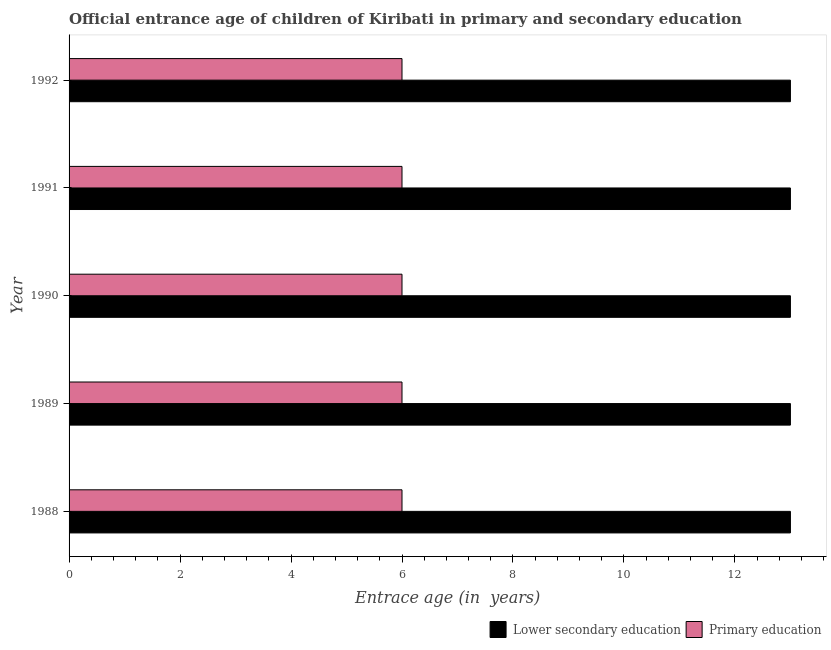How many different coloured bars are there?
Provide a succinct answer. 2. Are the number of bars per tick equal to the number of legend labels?
Offer a terse response. Yes. How many bars are there on the 4th tick from the top?
Provide a short and direct response. 2. What is the label of the 2nd group of bars from the top?
Offer a very short reply. 1991. Across all years, what is the minimum entrance age of children in lower secondary education?
Provide a succinct answer. 13. In which year was the entrance age of children in lower secondary education minimum?
Ensure brevity in your answer.  1988. What is the total entrance age of children in lower secondary education in the graph?
Keep it short and to the point. 65. What is the difference between the entrance age of children in lower secondary education in 1989 and the entrance age of chiildren in primary education in 1988?
Give a very brief answer. 7. What is the average entrance age of chiildren in primary education per year?
Keep it short and to the point. 6. In the year 1990, what is the difference between the entrance age of children in lower secondary education and entrance age of chiildren in primary education?
Provide a short and direct response. 7. In how many years, is the entrance age of chiildren in primary education greater than 6.8 years?
Provide a succinct answer. 0. Is the difference between the entrance age of chiildren in primary education in 1990 and 1991 greater than the difference between the entrance age of children in lower secondary education in 1990 and 1991?
Provide a short and direct response. No. What is the difference between the highest and the second highest entrance age of children in lower secondary education?
Ensure brevity in your answer.  0. What is the difference between the highest and the lowest entrance age of chiildren in primary education?
Offer a very short reply. 0. What does the 1st bar from the top in 1992 represents?
Ensure brevity in your answer.  Primary education. What does the 2nd bar from the bottom in 1989 represents?
Give a very brief answer. Primary education. How many bars are there?
Offer a terse response. 10. Are all the bars in the graph horizontal?
Offer a terse response. Yes. What is the difference between two consecutive major ticks on the X-axis?
Offer a terse response. 2. Where does the legend appear in the graph?
Your response must be concise. Bottom right. How are the legend labels stacked?
Ensure brevity in your answer.  Horizontal. What is the title of the graph?
Your response must be concise. Official entrance age of children of Kiribati in primary and secondary education. What is the label or title of the X-axis?
Offer a terse response. Entrace age (in  years). What is the Entrace age (in  years) in Lower secondary education in 1988?
Ensure brevity in your answer.  13. What is the Entrace age (in  years) of Primary education in 1988?
Ensure brevity in your answer.  6. What is the Entrace age (in  years) in Lower secondary education in 1989?
Offer a terse response. 13. What is the Entrace age (in  years) in Lower secondary education in 1991?
Keep it short and to the point. 13. What is the Entrace age (in  years) of Lower secondary education in 1992?
Provide a succinct answer. 13. Across all years, what is the maximum Entrace age (in  years) of Lower secondary education?
Your answer should be very brief. 13. Across all years, what is the minimum Entrace age (in  years) of Lower secondary education?
Give a very brief answer. 13. Across all years, what is the minimum Entrace age (in  years) in Primary education?
Give a very brief answer. 6. What is the total Entrace age (in  years) of Primary education in the graph?
Ensure brevity in your answer.  30. What is the difference between the Entrace age (in  years) in Lower secondary education in 1988 and that in 1989?
Provide a succinct answer. 0. What is the difference between the Entrace age (in  years) of Lower secondary education in 1988 and that in 1990?
Your answer should be compact. 0. What is the difference between the Entrace age (in  years) of Primary education in 1988 and that in 1990?
Provide a succinct answer. 0. What is the difference between the Entrace age (in  years) in Lower secondary education in 1988 and that in 1992?
Provide a short and direct response. 0. What is the difference between the Entrace age (in  years) of Primary education in 1989 and that in 1990?
Offer a very short reply. 0. What is the difference between the Entrace age (in  years) of Primary education in 1989 and that in 1991?
Your answer should be compact. 0. What is the difference between the Entrace age (in  years) in Lower secondary education in 1990 and that in 1991?
Your answer should be compact. 0. What is the difference between the Entrace age (in  years) in Primary education in 1990 and that in 1991?
Keep it short and to the point. 0. What is the difference between the Entrace age (in  years) of Lower secondary education in 1990 and that in 1992?
Offer a very short reply. 0. What is the difference between the Entrace age (in  years) of Lower secondary education in 1988 and the Entrace age (in  years) of Primary education in 1989?
Your answer should be very brief. 7. What is the difference between the Entrace age (in  years) of Lower secondary education in 1988 and the Entrace age (in  years) of Primary education in 1991?
Your answer should be very brief. 7. What is the difference between the Entrace age (in  years) of Lower secondary education in 1989 and the Entrace age (in  years) of Primary education in 1990?
Your response must be concise. 7. What is the difference between the Entrace age (in  years) in Lower secondary education in 1990 and the Entrace age (in  years) in Primary education in 1991?
Your answer should be very brief. 7. What is the difference between the Entrace age (in  years) of Lower secondary education in 1991 and the Entrace age (in  years) of Primary education in 1992?
Your answer should be compact. 7. In the year 1988, what is the difference between the Entrace age (in  years) of Lower secondary education and Entrace age (in  years) of Primary education?
Ensure brevity in your answer.  7. In the year 1990, what is the difference between the Entrace age (in  years) of Lower secondary education and Entrace age (in  years) of Primary education?
Your response must be concise. 7. In the year 1992, what is the difference between the Entrace age (in  years) of Lower secondary education and Entrace age (in  years) of Primary education?
Provide a short and direct response. 7. What is the ratio of the Entrace age (in  years) of Primary education in 1988 to that in 1989?
Make the answer very short. 1. What is the ratio of the Entrace age (in  years) of Primary education in 1988 to that in 1990?
Your answer should be very brief. 1. What is the ratio of the Entrace age (in  years) of Lower secondary education in 1988 to that in 1991?
Your response must be concise. 1. What is the ratio of the Entrace age (in  years) in Lower secondary education in 1989 to that in 1991?
Make the answer very short. 1. What is the ratio of the Entrace age (in  years) of Primary education in 1989 to that in 1991?
Offer a very short reply. 1. What is the ratio of the Entrace age (in  years) in Primary education in 1989 to that in 1992?
Provide a short and direct response. 1. What is the ratio of the Entrace age (in  years) of Primary education in 1990 to that in 1991?
Provide a succinct answer. 1. What is the ratio of the Entrace age (in  years) in Primary education in 1990 to that in 1992?
Give a very brief answer. 1. What is the ratio of the Entrace age (in  years) in Lower secondary education in 1991 to that in 1992?
Your response must be concise. 1. What is the difference between the highest and the second highest Entrace age (in  years) in Lower secondary education?
Offer a very short reply. 0. What is the difference between the highest and the lowest Entrace age (in  years) of Lower secondary education?
Provide a short and direct response. 0. What is the difference between the highest and the lowest Entrace age (in  years) of Primary education?
Provide a succinct answer. 0. 